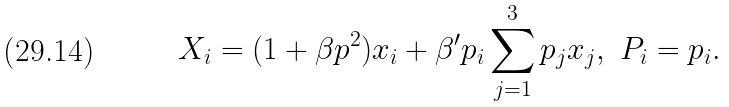Convert formula to latex. <formula><loc_0><loc_0><loc_500><loc_500>X _ { i } = ( 1 + \beta p ^ { 2 } ) x _ { i } + \beta ^ { \prime } p _ { i } \sum _ { j = 1 } ^ { 3 } p _ { j } x _ { j } , \ P _ { i } = p _ { i } .</formula> 